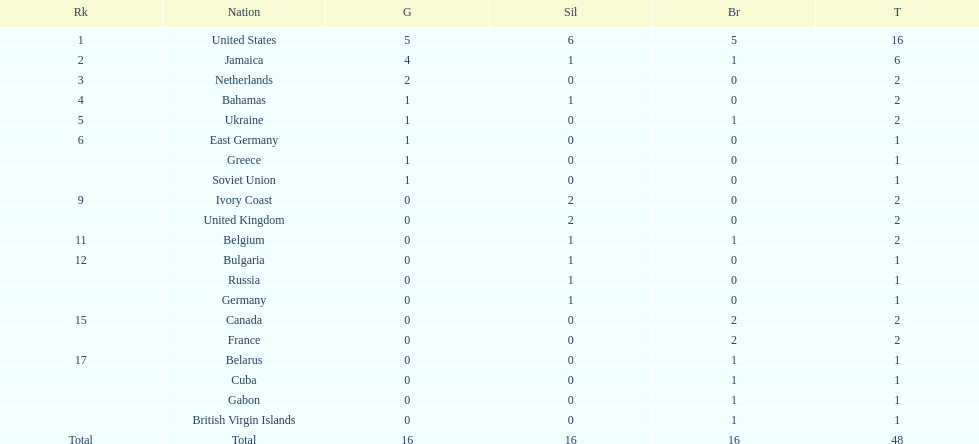Which countries won at least 3 silver medals? United States. 